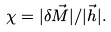<formula> <loc_0><loc_0><loc_500><loc_500>\chi = | \delta \vec { M } | / | \vec { h } | .</formula> 